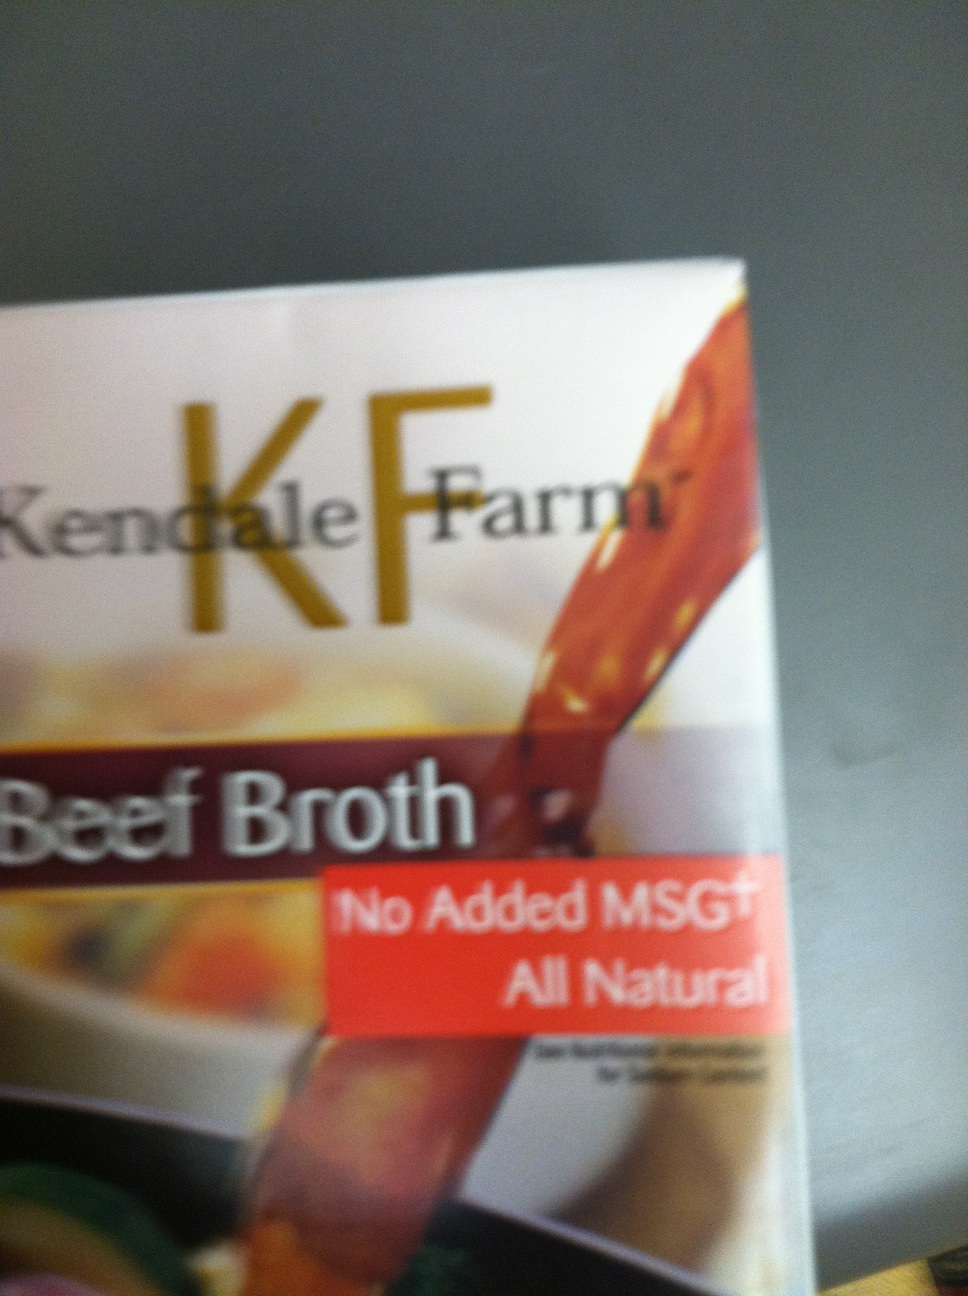Can you describe what this product is used for? This is a package of beef broth, which is commonly used as a base for soups and stews, or as a flavorful cooking liquid for rice, grains, and vegetables. It's also frequently used to deglaze pans or add depth to sauces and gravies. What are the health benefits of beef broth? Beef broth is rich in minerals that help build and strengthen bones. It contains essential amino acids, collagen, and gelatin which are beneficial for joint and gut health. Additionally, it is hydrating and can support a healthy immune system. Can you give me a simple recipe using this broth? Certainly! Here's a simple beef barley soup recipe:

Ingredients:
- 1 tablespoon olive oil
- 1 onion, chopped
- 2 carrots, sliced
- 2 celery stalks, sliced
- 2 cloves garlic, minced
- 1 pound beef stew meat, cubed
- 6 cups beef broth
- 1 cup pearl barley
- Salt and pepper to taste
- Fresh herbs for garnish (optional)

Instructions:
1. Heat olive oil in a large pot over medium heat. Add the onion, carrots, celery, and garlic, and sauté until vegetables are tender.
2. Add the beef stew meat and cook until browned on all sides.
3. Pour in the beef broth and bring to a boil. Add the pearl barley.
4. Reduce heat and let simmer for about an hour, or until the barley and meat are tender.
5. Season with salt and pepper to taste.
6. Garnish with fresh herbs if desired. Enjoy your hearty beef barley soup! 